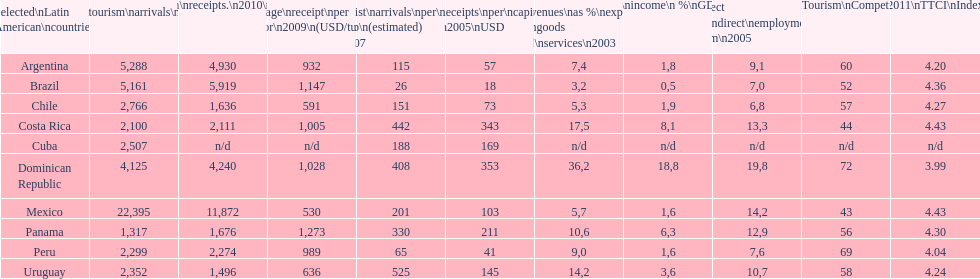Tourism income in latin american countries in 2003 was at most what percentage of gdp? 18,8. 